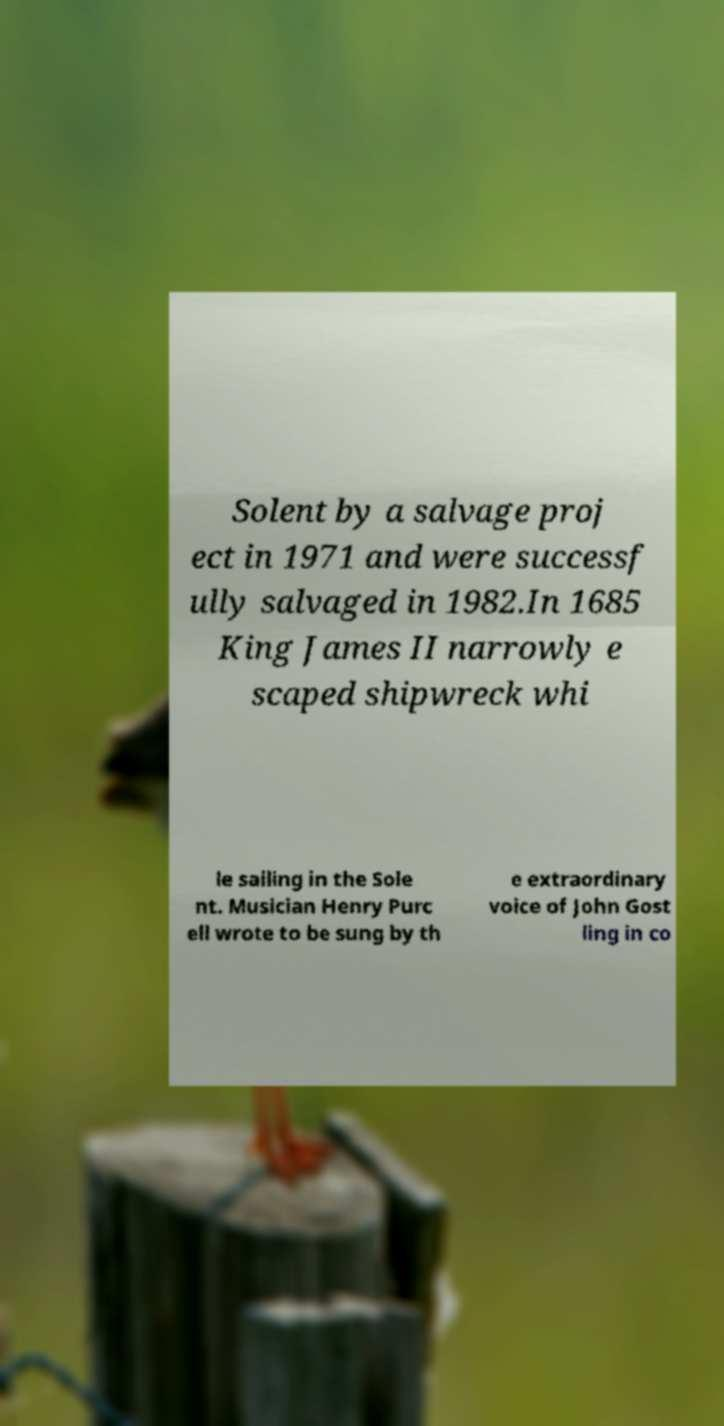Can you read and provide the text displayed in the image?This photo seems to have some interesting text. Can you extract and type it out for me? Solent by a salvage proj ect in 1971 and were successf ully salvaged in 1982.In 1685 King James II narrowly e scaped shipwreck whi le sailing in the Sole nt. Musician Henry Purc ell wrote to be sung by th e extraordinary voice of John Gost ling in co 